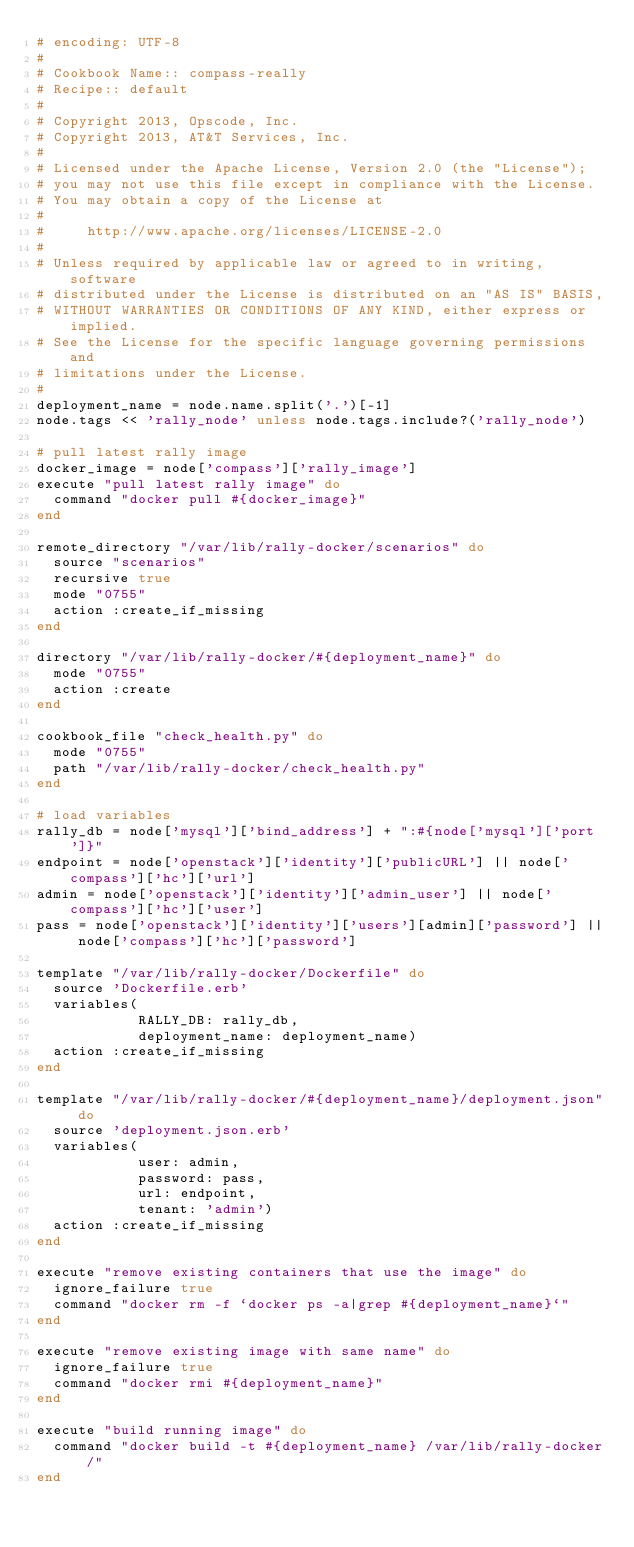Convert code to text. <code><loc_0><loc_0><loc_500><loc_500><_Ruby_># encoding: UTF-8
#
# Cookbook Name:: compass-really
# Recipe:: default
#
# Copyright 2013, Opscode, Inc.
# Copyright 2013, AT&T Services, Inc.
#
# Licensed under the Apache License, Version 2.0 (the "License");
# you may not use this file except in compliance with the License.
# You may obtain a copy of the License at
#
#     http://www.apache.org/licenses/LICENSE-2.0
#
# Unless required by applicable law or agreed to in writing, software
# distributed under the License is distributed on an "AS IS" BASIS,
# WITHOUT WARRANTIES OR CONDITIONS OF ANY KIND, either express or implied.
# See the License for the specific language governing permissions and
# limitations under the License.
#
deployment_name = node.name.split('.')[-1]
node.tags << 'rally_node' unless node.tags.include?('rally_node')

# pull latest rally image
docker_image = node['compass']['rally_image']
execute "pull latest rally image" do
  command "docker pull #{docker_image}"
end

remote_directory "/var/lib/rally-docker/scenarios" do
  source "scenarios"
  recursive true
  mode "0755"
  action :create_if_missing
end

directory "/var/lib/rally-docker/#{deployment_name}" do
  mode "0755"
  action :create
end

cookbook_file "check_health.py" do
  mode "0755"
  path "/var/lib/rally-docker/check_health.py"
end

# load variables
rally_db = node['mysql']['bind_address'] + ":#{node['mysql']['port']}"
endpoint = node['openstack']['identity']['publicURL'] || node['compass']['hc']['url'] 
admin = node['openstack']['identity']['admin_user'] || node['compass']['hc']['user']
pass = node['openstack']['identity']['users'][admin]['password'] || node['compass']['hc']['password']

template "/var/lib/rally-docker/Dockerfile" do
  source 'Dockerfile.erb'
  variables(
            RALLY_DB: rally_db,
            deployment_name: deployment_name)
  action :create_if_missing
end

template "/var/lib/rally-docker/#{deployment_name}/deployment.json" do
  source 'deployment.json.erb'
  variables(
            user: admin,
            password: pass,
            url: endpoint,
            tenant: 'admin')
  action :create_if_missing
end

execute "remove existing containers that use the image" do
  ignore_failure true
  command "docker rm -f `docker ps -a|grep #{deployment_name}`"
end

execute "remove existing image with same name" do
  ignore_failure true
  command "docker rmi #{deployment_name}"
end

execute "build running image" do
  command "docker build -t #{deployment_name} /var/lib/rally-docker/"
end
</code> 